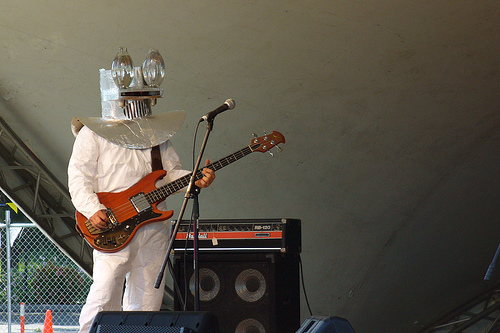<image>
Can you confirm if the guitar is under the man? No. The guitar is not positioned under the man. The vertical relationship between these objects is different. Is there a robot to the left of the microphone? Yes. From this viewpoint, the robot is positioned to the left side relative to the microphone. 